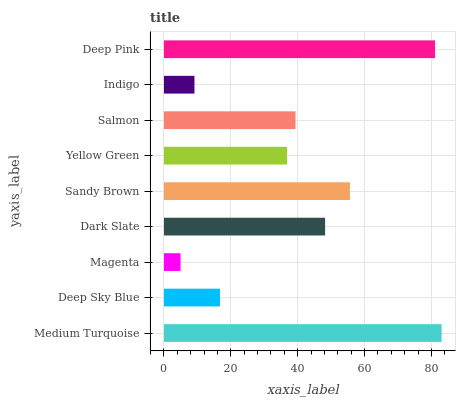Is Magenta the minimum?
Answer yes or no. Yes. Is Medium Turquoise the maximum?
Answer yes or no. Yes. Is Deep Sky Blue the minimum?
Answer yes or no. No. Is Deep Sky Blue the maximum?
Answer yes or no. No. Is Medium Turquoise greater than Deep Sky Blue?
Answer yes or no. Yes. Is Deep Sky Blue less than Medium Turquoise?
Answer yes or no. Yes. Is Deep Sky Blue greater than Medium Turquoise?
Answer yes or no. No. Is Medium Turquoise less than Deep Sky Blue?
Answer yes or no. No. Is Salmon the high median?
Answer yes or no. Yes. Is Salmon the low median?
Answer yes or no. Yes. Is Magenta the high median?
Answer yes or no. No. Is Deep Sky Blue the low median?
Answer yes or no. No. 